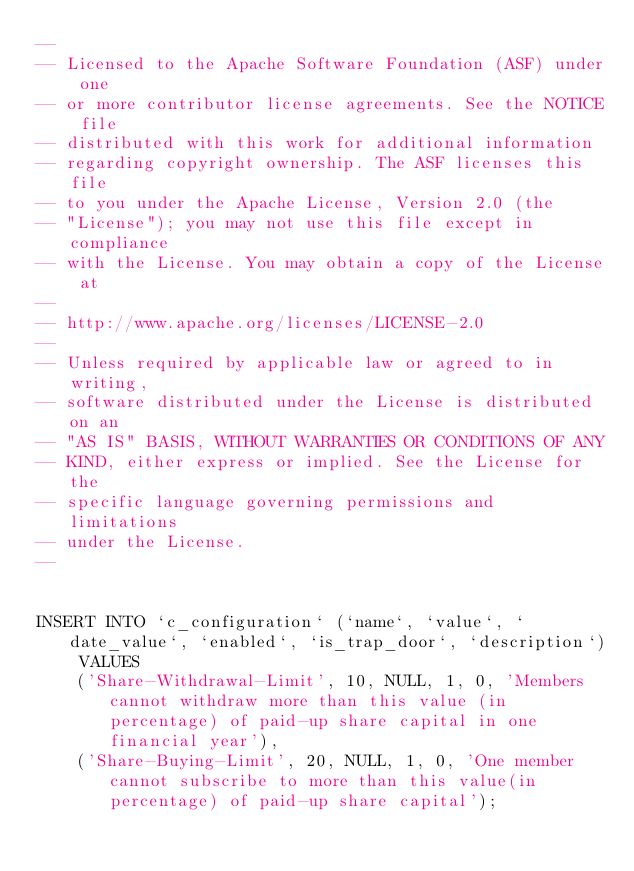Convert code to text. <code><loc_0><loc_0><loc_500><loc_500><_SQL_>--
-- Licensed to the Apache Software Foundation (ASF) under one
-- or more contributor license agreements. See the NOTICE file
-- distributed with this work for additional information
-- regarding copyright ownership. The ASF licenses this file
-- to you under the Apache License, Version 2.0 (the
-- "License"); you may not use this file except in compliance
-- with the License. You may obtain a copy of the License at
--
-- http://www.apache.org/licenses/LICENSE-2.0
--
-- Unless required by applicable law or agreed to in writing,
-- software distributed under the License is distributed on an
-- "AS IS" BASIS, WITHOUT WARRANTIES OR CONDITIONS OF ANY
-- KIND, either express or implied. See the License for the
-- specific language governing permissions and limitations
-- under the License.
--


INSERT INTO `c_configuration` (`name`, `value`, `date_value`, `enabled`, `is_trap_door`, `description`) VALUES
	('Share-Withdrawal-Limit', 10, NULL, 1, 0, 'Members cannot withdraw more than this value (in percentage) of paid-up share capital in one financial year'),
	('Share-Buying-Limit', 20, NULL, 1, 0, 'One member cannot subscribe to more than this value(in percentage) of paid-up share capital');</code> 